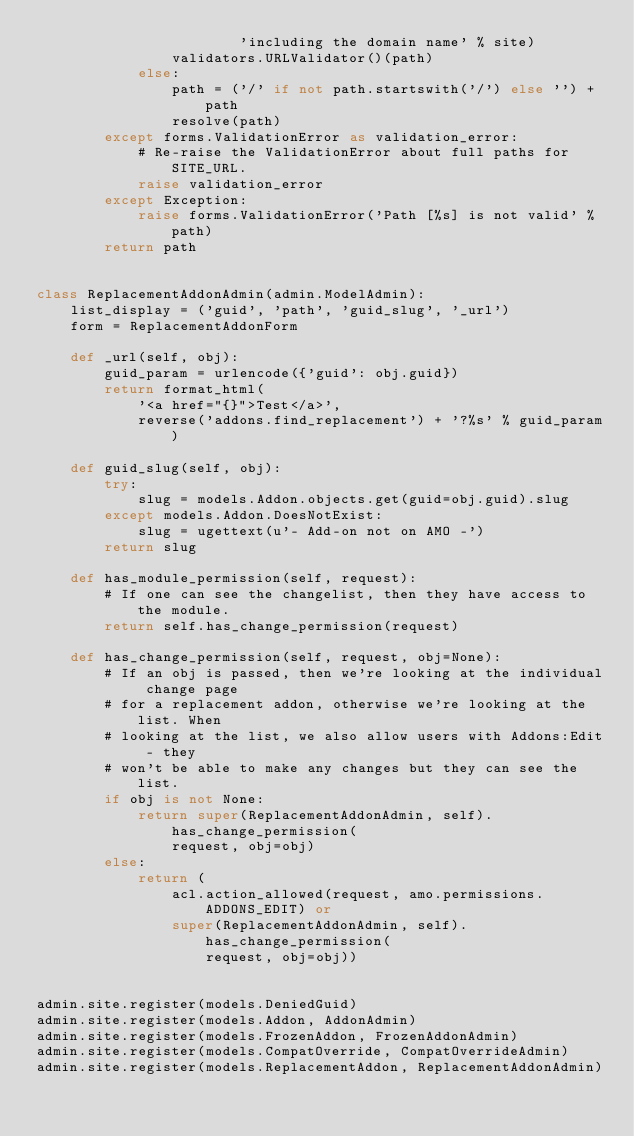Convert code to text. <code><loc_0><loc_0><loc_500><loc_500><_Python_>                        'including the domain name' % site)
                validators.URLValidator()(path)
            else:
                path = ('/' if not path.startswith('/') else '') + path
                resolve(path)
        except forms.ValidationError as validation_error:
            # Re-raise the ValidationError about full paths for SITE_URL.
            raise validation_error
        except Exception:
            raise forms.ValidationError('Path [%s] is not valid' % path)
        return path


class ReplacementAddonAdmin(admin.ModelAdmin):
    list_display = ('guid', 'path', 'guid_slug', '_url')
    form = ReplacementAddonForm

    def _url(self, obj):
        guid_param = urlencode({'guid': obj.guid})
        return format_html(
            '<a href="{}">Test</a>',
            reverse('addons.find_replacement') + '?%s' % guid_param)

    def guid_slug(self, obj):
        try:
            slug = models.Addon.objects.get(guid=obj.guid).slug
        except models.Addon.DoesNotExist:
            slug = ugettext(u'- Add-on not on AMO -')
        return slug

    def has_module_permission(self, request):
        # If one can see the changelist, then they have access to the module.
        return self.has_change_permission(request)

    def has_change_permission(self, request, obj=None):
        # If an obj is passed, then we're looking at the individual change page
        # for a replacement addon, otherwise we're looking at the list. When
        # looking at the list, we also allow users with Addons:Edit - they
        # won't be able to make any changes but they can see the list.
        if obj is not None:
            return super(ReplacementAddonAdmin, self).has_change_permission(
                request, obj=obj)
        else:
            return (
                acl.action_allowed(request, amo.permissions.ADDONS_EDIT) or
                super(ReplacementAddonAdmin, self).has_change_permission(
                    request, obj=obj))


admin.site.register(models.DeniedGuid)
admin.site.register(models.Addon, AddonAdmin)
admin.site.register(models.FrozenAddon, FrozenAddonAdmin)
admin.site.register(models.CompatOverride, CompatOverrideAdmin)
admin.site.register(models.ReplacementAddon, ReplacementAddonAdmin)
</code> 